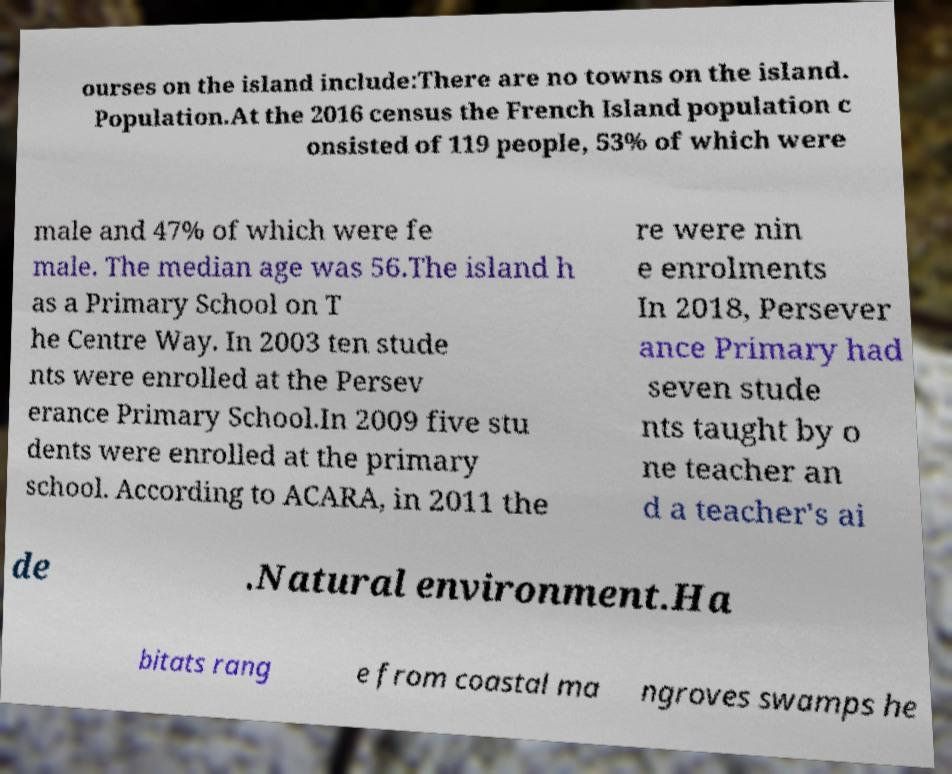Please read and relay the text visible in this image. What does it say? ourses on the island include:There are no towns on the island. Population.At the 2016 census the French Island population c onsisted of 119 people, 53% of which were male and 47% of which were fe male. The median age was 56.The island h as a Primary School on T he Centre Way. In 2003 ten stude nts were enrolled at the Persev erance Primary School.In 2009 five stu dents were enrolled at the primary school. According to ACARA, in 2011 the re were nin e enrolments In 2018, Persever ance Primary had seven stude nts taught by o ne teacher an d a teacher's ai de .Natural environment.Ha bitats rang e from coastal ma ngroves swamps he 